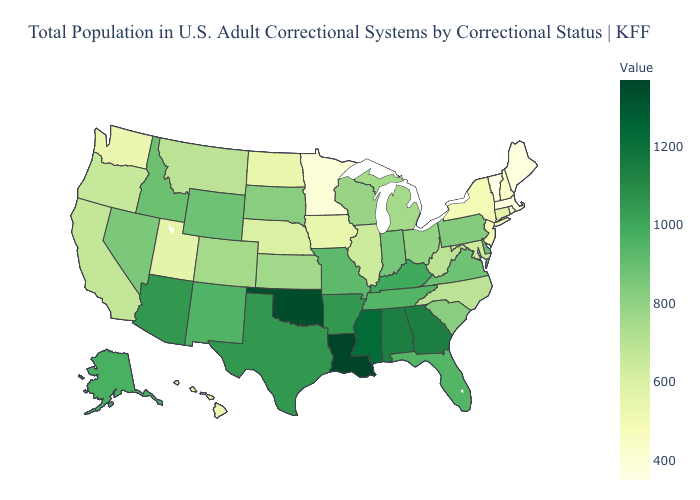Among the states that border New York , which have the highest value?
Write a very short answer. Pennsylvania. Among the states that border Mississippi , which have the lowest value?
Concise answer only. Tennessee. Does Pennsylvania have the highest value in the Northeast?
Keep it brief. Yes. Does Wisconsin have a higher value than Tennessee?
Quick response, please. No. Does Vermont have the lowest value in the USA?
Short answer required. Yes. Among the states that border Indiana , does Kentucky have the highest value?
Quick response, please. Yes. Does Vermont have the lowest value in the USA?
Give a very brief answer. Yes. Among the states that border Minnesota , which have the highest value?
Write a very short answer. South Dakota. 